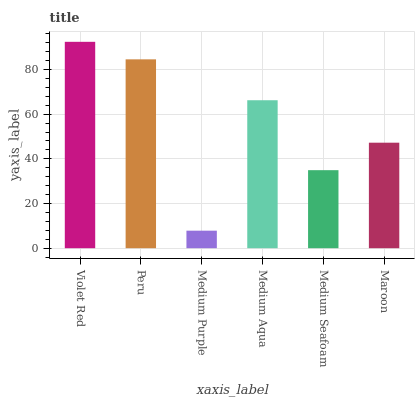Is Medium Purple the minimum?
Answer yes or no. Yes. Is Violet Red the maximum?
Answer yes or no. Yes. Is Peru the minimum?
Answer yes or no. No. Is Peru the maximum?
Answer yes or no. No. Is Violet Red greater than Peru?
Answer yes or no. Yes. Is Peru less than Violet Red?
Answer yes or no. Yes. Is Peru greater than Violet Red?
Answer yes or no. No. Is Violet Red less than Peru?
Answer yes or no. No. Is Medium Aqua the high median?
Answer yes or no. Yes. Is Maroon the low median?
Answer yes or no. Yes. Is Medium Seafoam the high median?
Answer yes or no. No. Is Medium Purple the low median?
Answer yes or no. No. 